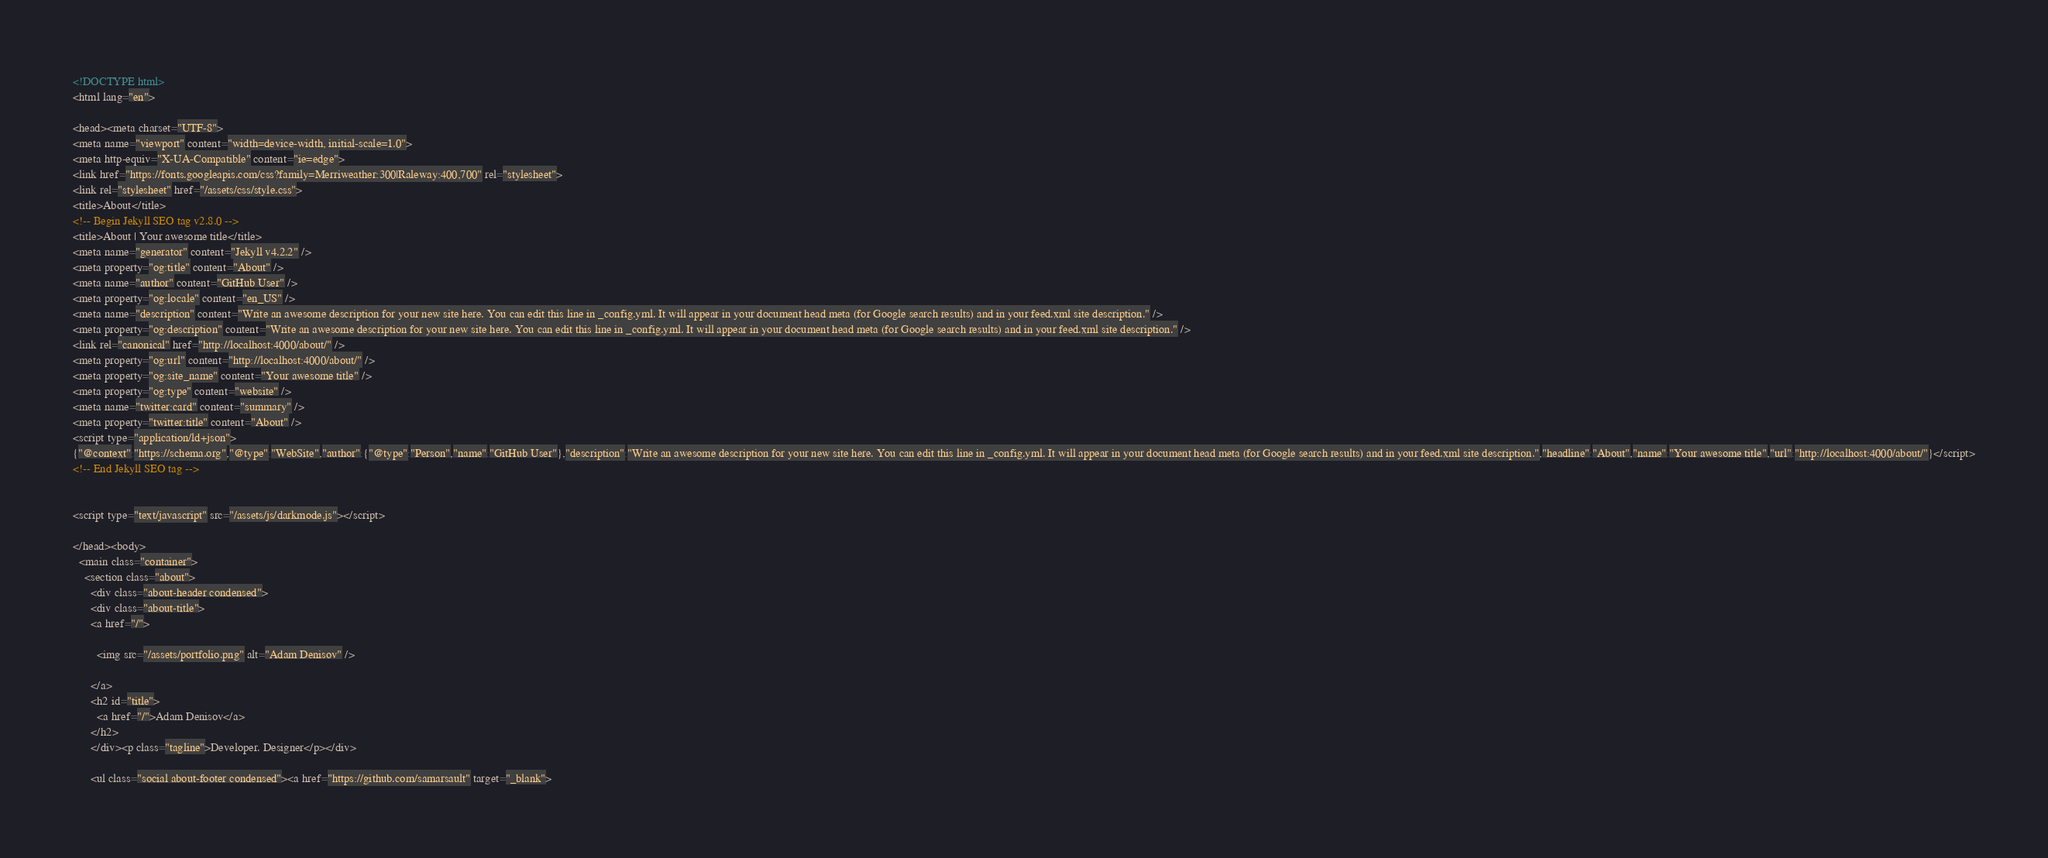Convert code to text. <code><loc_0><loc_0><loc_500><loc_500><_HTML_><!DOCTYPE html>
<html lang="en">

<head><meta charset="UTF-8">
<meta name="viewport" content="width=device-width, initial-scale=1.0">
<meta http-equiv="X-UA-Compatible" content="ie=edge">
<link href="https://fonts.googleapis.com/css?family=Merriweather:300|Raleway:400,700" rel="stylesheet">
<link rel="stylesheet" href="/assets/css/style.css">
<title>About</title>
<!-- Begin Jekyll SEO tag v2.8.0 -->
<title>About | Your awesome title</title>
<meta name="generator" content="Jekyll v4.2.2" />
<meta property="og:title" content="About" />
<meta name="author" content="GitHub User" />
<meta property="og:locale" content="en_US" />
<meta name="description" content="Write an awesome description for your new site here. You can edit this line in _config.yml. It will appear in your document head meta (for Google search results) and in your feed.xml site description." />
<meta property="og:description" content="Write an awesome description for your new site here. You can edit this line in _config.yml. It will appear in your document head meta (for Google search results) and in your feed.xml site description." />
<link rel="canonical" href="http://localhost:4000/about/" />
<meta property="og:url" content="http://localhost:4000/about/" />
<meta property="og:site_name" content="Your awesome title" />
<meta property="og:type" content="website" />
<meta name="twitter:card" content="summary" />
<meta property="twitter:title" content="About" />
<script type="application/ld+json">
{"@context":"https://schema.org","@type":"WebSite","author":{"@type":"Person","name":"GitHub User"},"description":"Write an awesome description for your new site here. You can edit this line in _config.yml. It will appear in your document head meta (for Google search results) and in your feed.xml site description.","headline":"About","name":"Your awesome title","url":"http://localhost:4000/about/"}</script>
<!-- End Jekyll SEO tag -->


<script type="text/javascript" src="/assets/js/darkmode.js"></script>

</head><body>
  <main class="container">
    <section class="about">
      <div class="about-header condensed">
      <div class="about-title">
      <a href="/">
        
        <img src="/assets/portfolio.png" alt="Adam Denisov" />
        
      </a>
      <h2 id="title">
        <a href="/">Adam Denisov</a>
      </h2>
      </div><p class="tagline">Developer. Designer</p></div>
      
      <ul class="social about-footer condensed"><a href="https://github.com/samarsault" target="_blank"></code> 